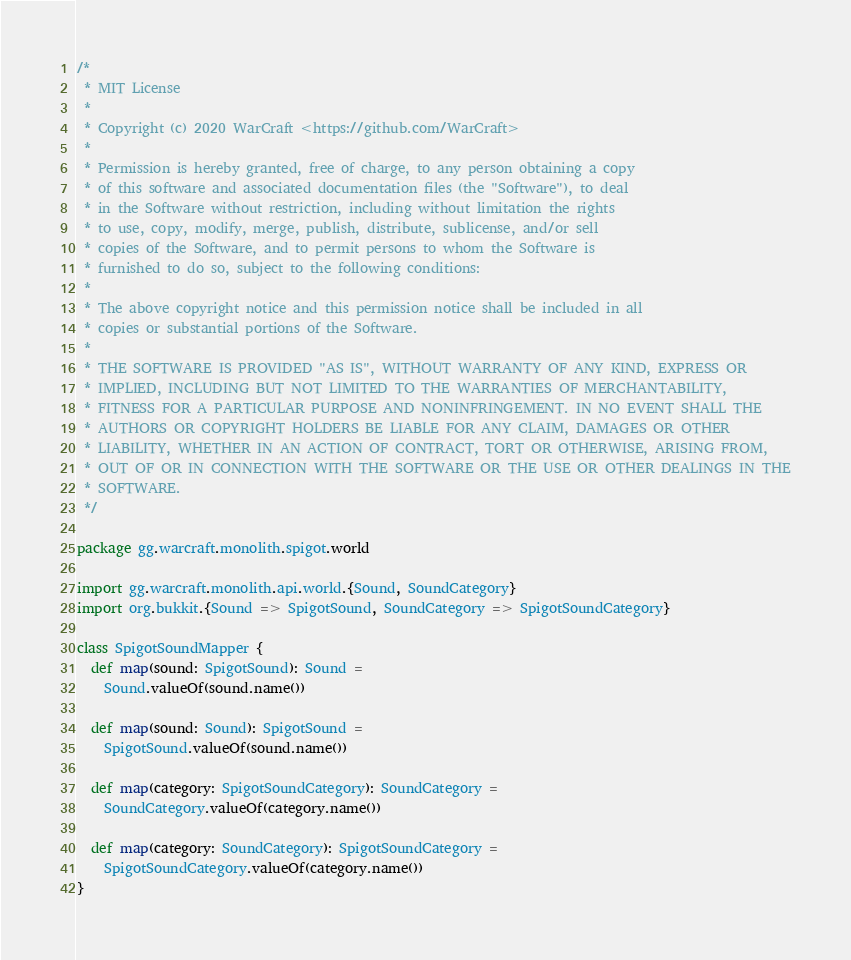<code> <loc_0><loc_0><loc_500><loc_500><_Scala_>/*
 * MIT License
 *
 * Copyright (c) 2020 WarCraft <https://github.com/WarCraft>
 *
 * Permission is hereby granted, free of charge, to any person obtaining a copy
 * of this software and associated documentation files (the "Software"), to deal
 * in the Software without restriction, including without limitation the rights
 * to use, copy, modify, merge, publish, distribute, sublicense, and/or sell
 * copies of the Software, and to permit persons to whom the Software is
 * furnished to do so, subject to the following conditions:
 *
 * The above copyright notice and this permission notice shall be included in all
 * copies or substantial portions of the Software.
 *
 * THE SOFTWARE IS PROVIDED "AS IS", WITHOUT WARRANTY OF ANY KIND, EXPRESS OR
 * IMPLIED, INCLUDING BUT NOT LIMITED TO THE WARRANTIES OF MERCHANTABILITY,
 * FITNESS FOR A PARTICULAR PURPOSE AND NONINFRINGEMENT. IN NO EVENT SHALL THE
 * AUTHORS OR COPYRIGHT HOLDERS BE LIABLE FOR ANY CLAIM, DAMAGES OR OTHER
 * LIABILITY, WHETHER IN AN ACTION OF CONTRACT, TORT OR OTHERWISE, ARISING FROM,
 * OUT OF OR IN CONNECTION WITH THE SOFTWARE OR THE USE OR OTHER DEALINGS IN THE
 * SOFTWARE.
 */

package gg.warcraft.monolith.spigot.world

import gg.warcraft.monolith.api.world.{Sound, SoundCategory}
import org.bukkit.{Sound => SpigotSound, SoundCategory => SpigotSoundCategory}

class SpigotSoundMapper {
  def map(sound: SpigotSound): Sound =
    Sound.valueOf(sound.name())

  def map(sound: Sound): SpigotSound =
    SpigotSound.valueOf(sound.name())

  def map(category: SpigotSoundCategory): SoundCategory =
    SoundCategory.valueOf(category.name())

  def map(category: SoundCategory): SpigotSoundCategory =
    SpigotSoundCategory.valueOf(category.name())
}
</code> 